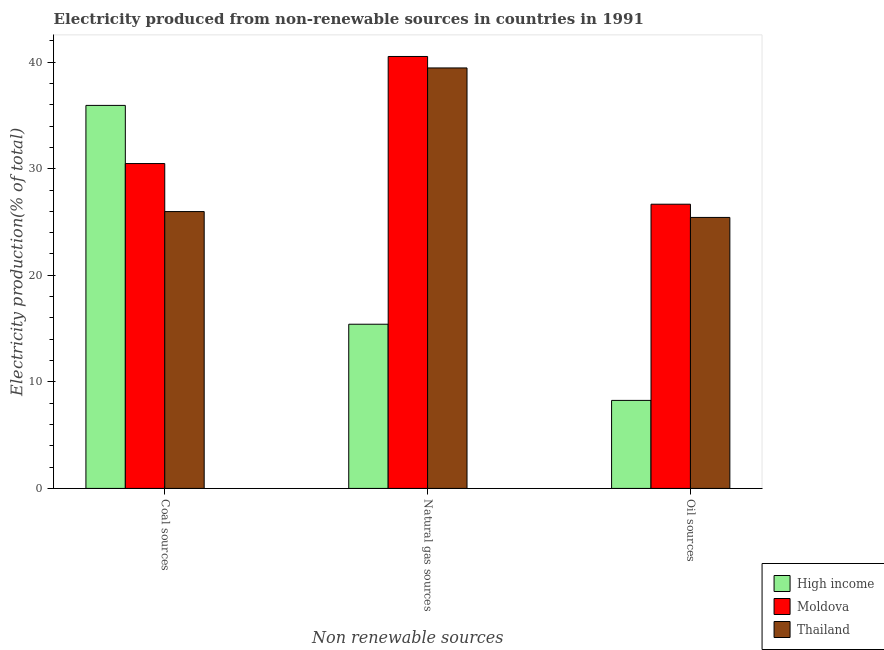How many different coloured bars are there?
Give a very brief answer. 3. Are the number of bars on each tick of the X-axis equal?
Your response must be concise. Yes. How many bars are there on the 1st tick from the right?
Keep it short and to the point. 3. What is the label of the 2nd group of bars from the left?
Provide a short and direct response. Natural gas sources. What is the percentage of electricity produced by oil sources in High income?
Your response must be concise. 8.26. Across all countries, what is the maximum percentage of electricity produced by coal?
Give a very brief answer. 35.94. Across all countries, what is the minimum percentage of electricity produced by natural gas?
Your response must be concise. 15.41. In which country was the percentage of electricity produced by coal maximum?
Offer a terse response. High income. In which country was the percentage of electricity produced by oil sources minimum?
Provide a succinct answer. High income. What is the total percentage of electricity produced by coal in the graph?
Offer a very short reply. 92.4. What is the difference between the percentage of electricity produced by coal in Thailand and that in High income?
Provide a short and direct response. -9.96. What is the difference between the percentage of electricity produced by oil sources in High income and the percentage of electricity produced by natural gas in Thailand?
Ensure brevity in your answer.  -31.2. What is the average percentage of electricity produced by oil sources per country?
Make the answer very short. 20.12. What is the difference between the percentage of electricity produced by oil sources and percentage of electricity produced by natural gas in High income?
Keep it short and to the point. -7.15. In how many countries, is the percentage of electricity produced by oil sources greater than 28 %?
Provide a short and direct response. 0. What is the ratio of the percentage of electricity produced by coal in Thailand to that in High income?
Offer a very short reply. 0.72. Is the difference between the percentage of electricity produced by oil sources in Thailand and High income greater than the difference between the percentage of electricity produced by coal in Thailand and High income?
Give a very brief answer. Yes. What is the difference between the highest and the second highest percentage of electricity produced by oil sources?
Your answer should be compact. 1.24. What is the difference between the highest and the lowest percentage of electricity produced by oil sources?
Give a very brief answer. 18.41. Is the sum of the percentage of electricity produced by coal in Moldova and Thailand greater than the maximum percentage of electricity produced by oil sources across all countries?
Provide a short and direct response. Yes. What does the 2nd bar from the left in Oil sources represents?
Keep it short and to the point. Moldova. What does the 2nd bar from the right in Oil sources represents?
Your answer should be very brief. Moldova. How many bars are there?
Your answer should be compact. 9. Does the graph contain grids?
Provide a short and direct response. No. Where does the legend appear in the graph?
Offer a terse response. Bottom right. How many legend labels are there?
Keep it short and to the point. 3. How are the legend labels stacked?
Your answer should be very brief. Vertical. What is the title of the graph?
Provide a succinct answer. Electricity produced from non-renewable sources in countries in 1991. What is the label or title of the X-axis?
Offer a very short reply. Non renewable sources. What is the label or title of the Y-axis?
Ensure brevity in your answer.  Electricity production(% of total). What is the Electricity production(% of total) in High income in Coal sources?
Give a very brief answer. 35.94. What is the Electricity production(% of total) of Moldova in Coal sources?
Provide a succinct answer. 30.48. What is the Electricity production(% of total) in Thailand in Coal sources?
Your response must be concise. 25.98. What is the Electricity production(% of total) of High income in Natural gas sources?
Keep it short and to the point. 15.41. What is the Electricity production(% of total) in Moldova in Natural gas sources?
Provide a short and direct response. 40.53. What is the Electricity production(% of total) of Thailand in Natural gas sources?
Make the answer very short. 39.45. What is the Electricity production(% of total) in High income in Oil sources?
Offer a terse response. 8.26. What is the Electricity production(% of total) of Moldova in Oil sources?
Offer a terse response. 26.67. What is the Electricity production(% of total) in Thailand in Oil sources?
Your answer should be very brief. 25.43. Across all Non renewable sources, what is the maximum Electricity production(% of total) of High income?
Your answer should be very brief. 35.94. Across all Non renewable sources, what is the maximum Electricity production(% of total) in Moldova?
Keep it short and to the point. 40.53. Across all Non renewable sources, what is the maximum Electricity production(% of total) in Thailand?
Provide a short and direct response. 39.45. Across all Non renewable sources, what is the minimum Electricity production(% of total) of High income?
Your answer should be very brief. 8.26. Across all Non renewable sources, what is the minimum Electricity production(% of total) in Moldova?
Provide a succinct answer. 26.67. Across all Non renewable sources, what is the minimum Electricity production(% of total) of Thailand?
Your answer should be compact. 25.43. What is the total Electricity production(% of total) of High income in the graph?
Provide a succinct answer. 59.6. What is the total Electricity production(% of total) of Moldova in the graph?
Your response must be concise. 97.68. What is the total Electricity production(% of total) in Thailand in the graph?
Your answer should be very brief. 90.86. What is the difference between the Electricity production(% of total) of High income in Coal sources and that in Natural gas sources?
Your answer should be compact. 20.53. What is the difference between the Electricity production(% of total) in Moldova in Coal sources and that in Natural gas sources?
Ensure brevity in your answer.  -10.05. What is the difference between the Electricity production(% of total) in Thailand in Coal sources and that in Natural gas sources?
Give a very brief answer. -13.48. What is the difference between the Electricity production(% of total) in High income in Coal sources and that in Oil sources?
Provide a short and direct response. 27.68. What is the difference between the Electricity production(% of total) in Moldova in Coal sources and that in Oil sources?
Your response must be concise. 3.81. What is the difference between the Electricity production(% of total) of Thailand in Coal sources and that in Oil sources?
Your answer should be very brief. 0.55. What is the difference between the Electricity production(% of total) of High income in Natural gas sources and that in Oil sources?
Ensure brevity in your answer.  7.15. What is the difference between the Electricity production(% of total) in Moldova in Natural gas sources and that in Oil sources?
Offer a very short reply. 13.86. What is the difference between the Electricity production(% of total) of Thailand in Natural gas sources and that in Oil sources?
Your answer should be very brief. 14.03. What is the difference between the Electricity production(% of total) in High income in Coal sources and the Electricity production(% of total) in Moldova in Natural gas sources?
Ensure brevity in your answer.  -4.59. What is the difference between the Electricity production(% of total) in High income in Coal sources and the Electricity production(% of total) in Thailand in Natural gas sources?
Offer a very short reply. -3.52. What is the difference between the Electricity production(% of total) in Moldova in Coal sources and the Electricity production(% of total) in Thailand in Natural gas sources?
Give a very brief answer. -8.97. What is the difference between the Electricity production(% of total) in High income in Coal sources and the Electricity production(% of total) in Moldova in Oil sources?
Offer a very short reply. 9.27. What is the difference between the Electricity production(% of total) in High income in Coal sources and the Electricity production(% of total) in Thailand in Oil sources?
Make the answer very short. 10.51. What is the difference between the Electricity production(% of total) in Moldova in Coal sources and the Electricity production(% of total) in Thailand in Oil sources?
Give a very brief answer. 5.05. What is the difference between the Electricity production(% of total) in High income in Natural gas sources and the Electricity production(% of total) in Moldova in Oil sources?
Provide a succinct answer. -11.26. What is the difference between the Electricity production(% of total) in High income in Natural gas sources and the Electricity production(% of total) in Thailand in Oil sources?
Your response must be concise. -10.02. What is the difference between the Electricity production(% of total) in Moldova in Natural gas sources and the Electricity production(% of total) in Thailand in Oil sources?
Provide a succinct answer. 15.1. What is the average Electricity production(% of total) of High income per Non renewable sources?
Keep it short and to the point. 19.87. What is the average Electricity production(% of total) in Moldova per Non renewable sources?
Give a very brief answer. 32.56. What is the average Electricity production(% of total) of Thailand per Non renewable sources?
Provide a short and direct response. 30.29. What is the difference between the Electricity production(% of total) in High income and Electricity production(% of total) in Moldova in Coal sources?
Ensure brevity in your answer.  5.46. What is the difference between the Electricity production(% of total) in High income and Electricity production(% of total) in Thailand in Coal sources?
Offer a terse response. 9.96. What is the difference between the Electricity production(% of total) of Moldova and Electricity production(% of total) of Thailand in Coal sources?
Offer a very short reply. 4.5. What is the difference between the Electricity production(% of total) of High income and Electricity production(% of total) of Moldova in Natural gas sources?
Your answer should be very brief. -25.12. What is the difference between the Electricity production(% of total) in High income and Electricity production(% of total) in Thailand in Natural gas sources?
Make the answer very short. -24.05. What is the difference between the Electricity production(% of total) of Moldova and Electricity production(% of total) of Thailand in Natural gas sources?
Provide a short and direct response. 1.08. What is the difference between the Electricity production(% of total) of High income and Electricity production(% of total) of Moldova in Oil sources?
Your answer should be compact. -18.41. What is the difference between the Electricity production(% of total) of High income and Electricity production(% of total) of Thailand in Oil sources?
Give a very brief answer. -17.17. What is the difference between the Electricity production(% of total) of Moldova and Electricity production(% of total) of Thailand in Oil sources?
Keep it short and to the point. 1.24. What is the ratio of the Electricity production(% of total) in High income in Coal sources to that in Natural gas sources?
Ensure brevity in your answer.  2.33. What is the ratio of the Electricity production(% of total) of Moldova in Coal sources to that in Natural gas sources?
Your response must be concise. 0.75. What is the ratio of the Electricity production(% of total) in Thailand in Coal sources to that in Natural gas sources?
Provide a short and direct response. 0.66. What is the ratio of the Electricity production(% of total) of High income in Coal sources to that in Oil sources?
Make the answer very short. 4.35. What is the ratio of the Electricity production(% of total) in Moldova in Coal sources to that in Oil sources?
Offer a terse response. 1.14. What is the ratio of the Electricity production(% of total) in Thailand in Coal sources to that in Oil sources?
Make the answer very short. 1.02. What is the ratio of the Electricity production(% of total) in High income in Natural gas sources to that in Oil sources?
Your answer should be very brief. 1.87. What is the ratio of the Electricity production(% of total) of Moldova in Natural gas sources to that in Oil sources?
Your response must be concise. 1.52. What is the ratio of the Electricity production(% of total) in Thailand in Natural gas sources to that in Oil sources?
Your response must be concise. 1.55. What is the difference between the highest and the second highest Electricity production(% of total) in High income?
Make the answer very short. 20.53. What is the difference between the highest and the second highest Electricity production(% of total) in Moldova?
Provide a succinct answer. 10.05. What is the difference between the highest and the second highest Electricity production(% of total) in Thailand?
Offer a terse response. 13.48. What is the difference between the highest and the lowest Electricity production(% of total) of High income?
Provide a short and direct response. 27.68. What is the difference between the highest and the lowest Electricity production(% of total) in Moldova?
Provide a short and direct response. 13.86. What is the difference between the highest and the lowest Electricity production(% of total) in Thailand?
Provide a short and direct response. 14.03. 